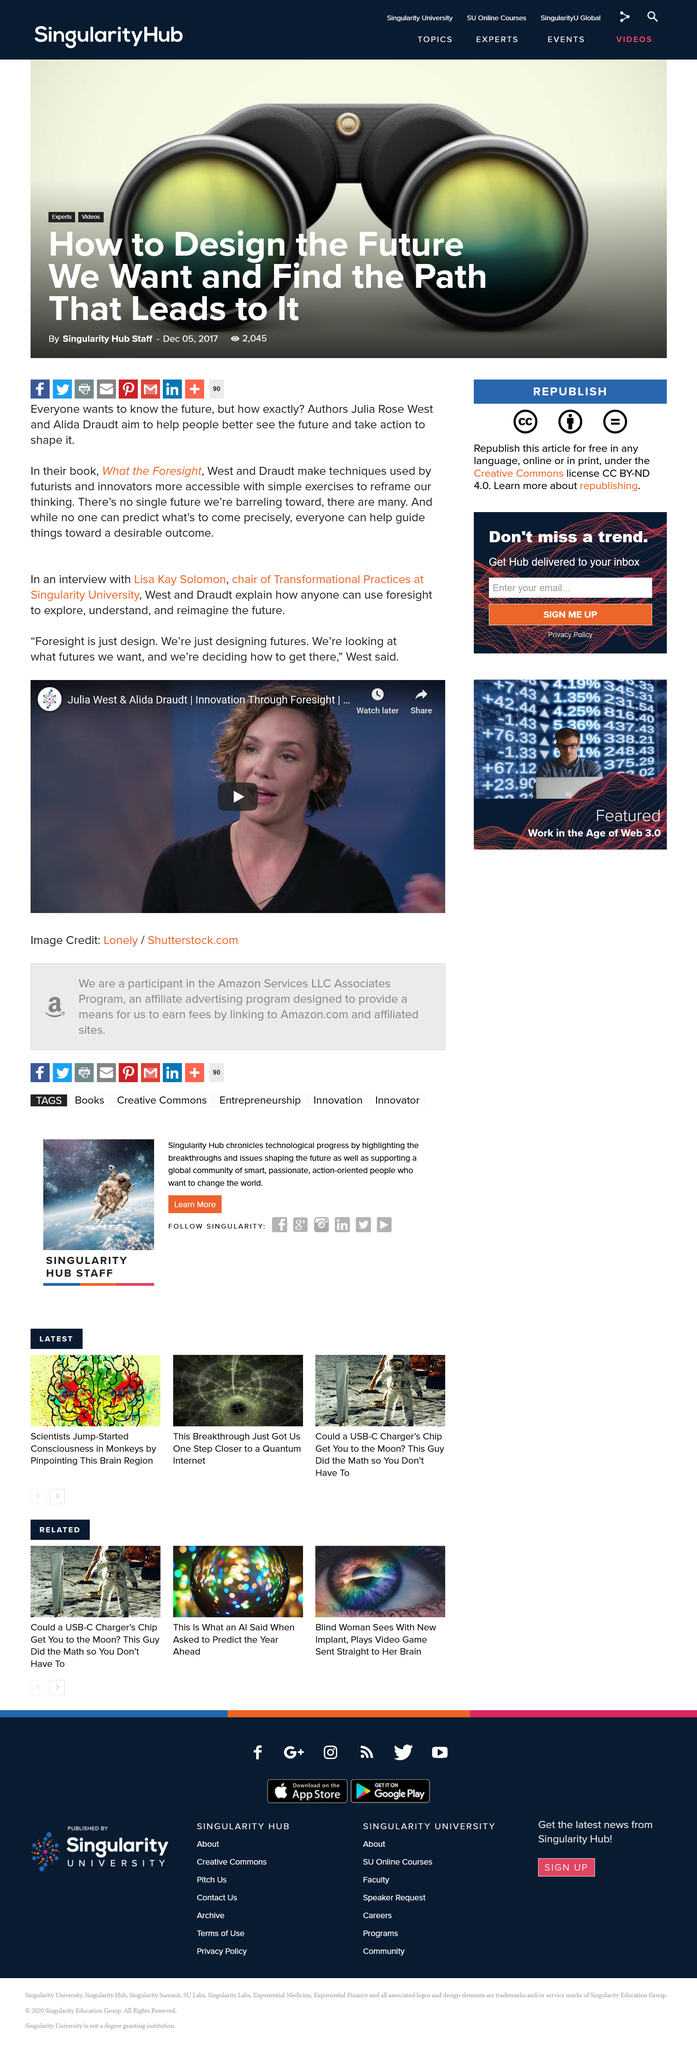Indicate a few pertinent items in this graphic. Using foresight involves exploring, understanding, and reimagining the future, allowing individuals to make informed decisions and shape their own future. Julia West and Alida Draudt are the authors of the book titled 'What the Foresight.' Lisa Kay Solomon is the chairman of Transformational Practices at Singularity University. 